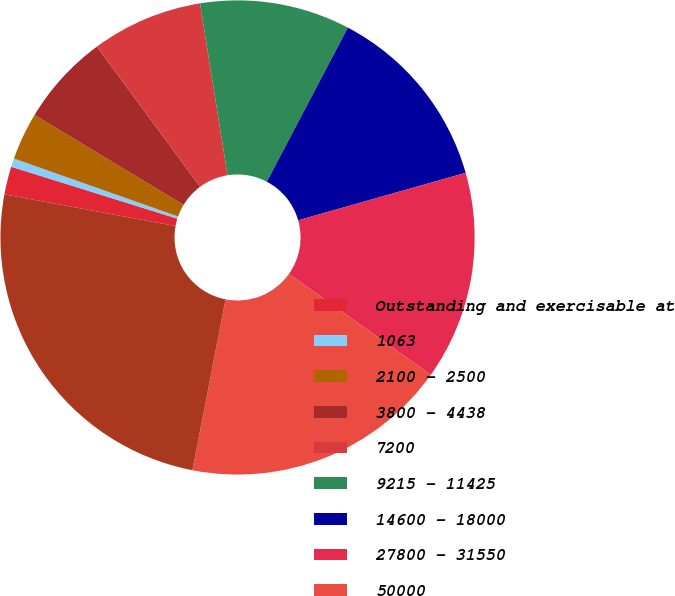Convert chart. <chart><loc_0><loc_0><loc_500><loc_500><pie_chart><fcel>Outstanding and exercisable at<fcel>1063<fcel>2100 - 2500<fcel>3800 - 4438<fcel>7200<fcel>9215 - 11425<fcel>14600 - 18000<fcel>27800 - 31550<fcel>50000<fcel>67100 - 76025<nl><fcel>1.91%<fcel>0.58%<fcel>3.24%<fcel>6.25%<fcel>7.58%<fcel>10.24%<fcel>12.9%<fcel>14.23%<fcel>18.22%<fcel>24.87%<nl></chart> 